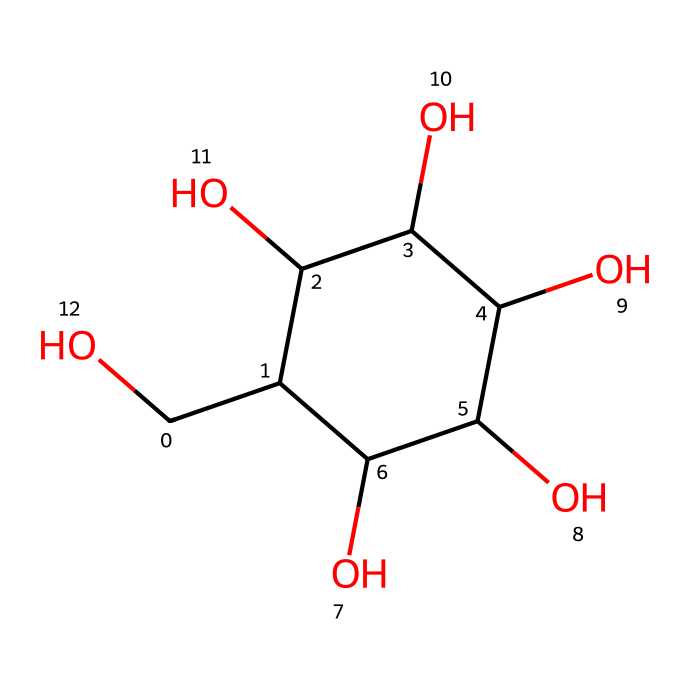What is the name of this chemical? The SMILES representation corresponds to the chemical structure of glucose, which is a common sugar and an important energy source.
Answer: glucose How many hydroxyl groups (-OH) are present in the molecule? By analyzing the structure represented in the SMILES notation, there are five -OH groups indicated by the presence of oxygen atoms connected to hydrogen.
Answer: five What is the total number of carbon atoms in the glucose molecule? The SMILES notation reveals six carbon atoms in total, which are represented by the 'C' in the structure.
Answer: six Can this molecule participate in hydrogen bonding? This molecule features multiple hydroxyl groups (-OH), which can act as hydrogen bond donors and acceptors, allowing for hydrogen bonding interactions.
Answer: yes What type of chemical is glucose classified as? Glucose is classified as a carbohydrate, specifically a monosaccharide, due to its structure comprising multiple hydroxyl groups and a carbon framework.
Answer: carbohydrate What is the molecular formula for glucose based on the chemical structure? By counting the constituents from the SMILES representation, glucose is found to have a molecular formula of C6H12O6, which includes six carbons, twelve hydrogens, and six oxygens.
Answer: C6H12O6 Does glucose exist in a solid, liquid, or gaseous state under standard conditions? Under standard conditions, glucose typically exists in solid form as a crystalline sugar, making it practically stable and non-volatile.
Answer: solid 